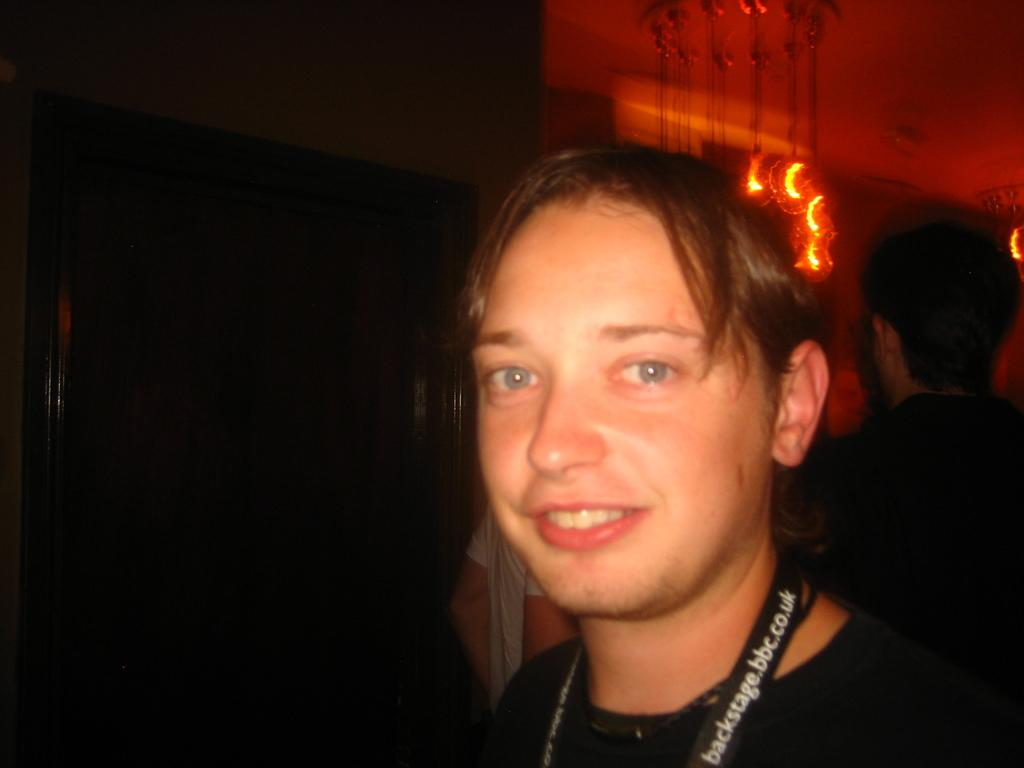What is the main subject of the image? The main subject of the image is a man. What is the man doing in the image? The man is smiling in the image. What color is the shirt the man is wearing? The man is wearing a black color shirt. Can you describe the object associated with the man? Unfortunately, the facts provided do not specify the object associated with the man. What can be seen in the background of the image? In the background of the image, there are people and lights. What type of hobbies does the man have, as seen in the image? The facts provided do not give any information about the man's hobbies, so we cannot determine his hobbies from the image. 